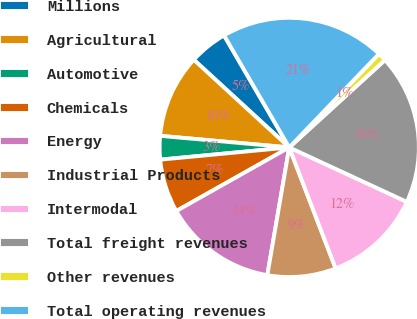Convert chart to OTSL. <chart><loc_0><loc_0><loc_500><loc_500><pie_chart><fcel>Millions<fcel>Agricultural<fcel>Automotive<fcel>Chemicals<fcel>Energy<fcel>Industrial Products<fcel>Intermodal<fcel>Total freight revenues<fcel>Other revenues<fcel>Total operating revenues<nl><fcel>4.79%<fcel>10.4%<fcel>2.93%<fcel>6.66%<fcel>14.13%<fcel>8.53%<fcel>12.27%<fcel>18.68%<fcel>1.06%<fcel>20.55%<nl></chart> 